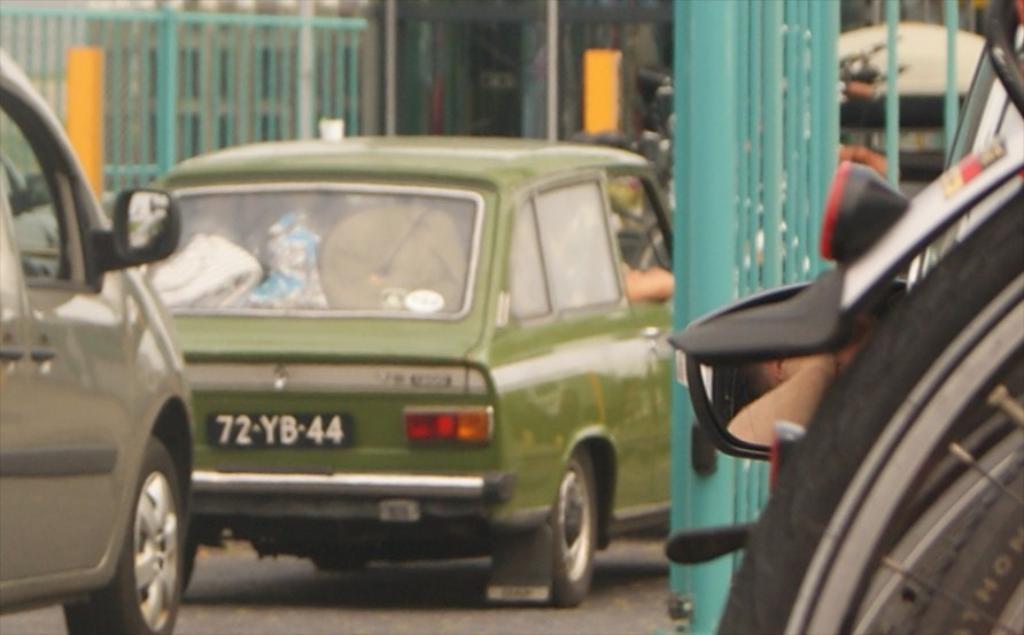In one or two sentences, can you explain what this image depicts? In this image there are cars, there is a car truncated towards the left of the image, there is road, there is a mirror, there is a vehicle truncated towards the right of the image, there is a fencing, there are objects truncated towards the top of the image. 